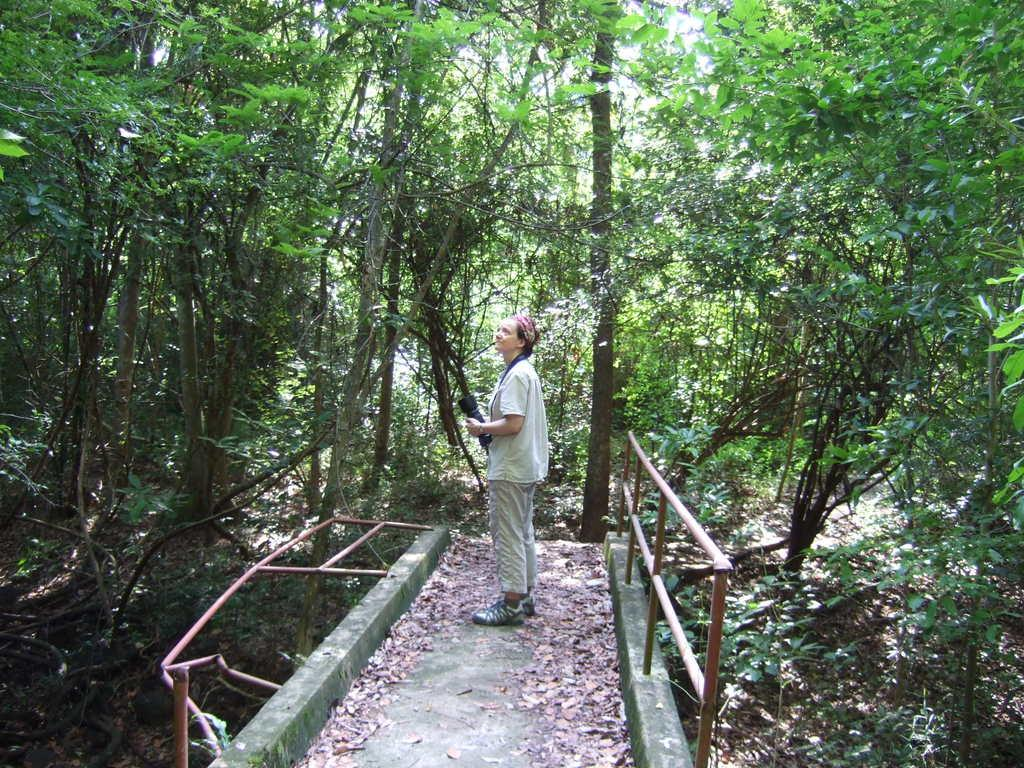What type of natural elements can be seen in the image? There are trees in the image. Can you describe the person in the image? There is a woman in the image. What is the woman wearing? The woman is wearing a white dress. What type of pollution can be seen in the image? There is no pollution visible in the image; it features trees and a woman wearing a white dress. Can you describe the bedroom in the image? There is no bedroom present in the image; it features trees and a woman wearing a white dress. 